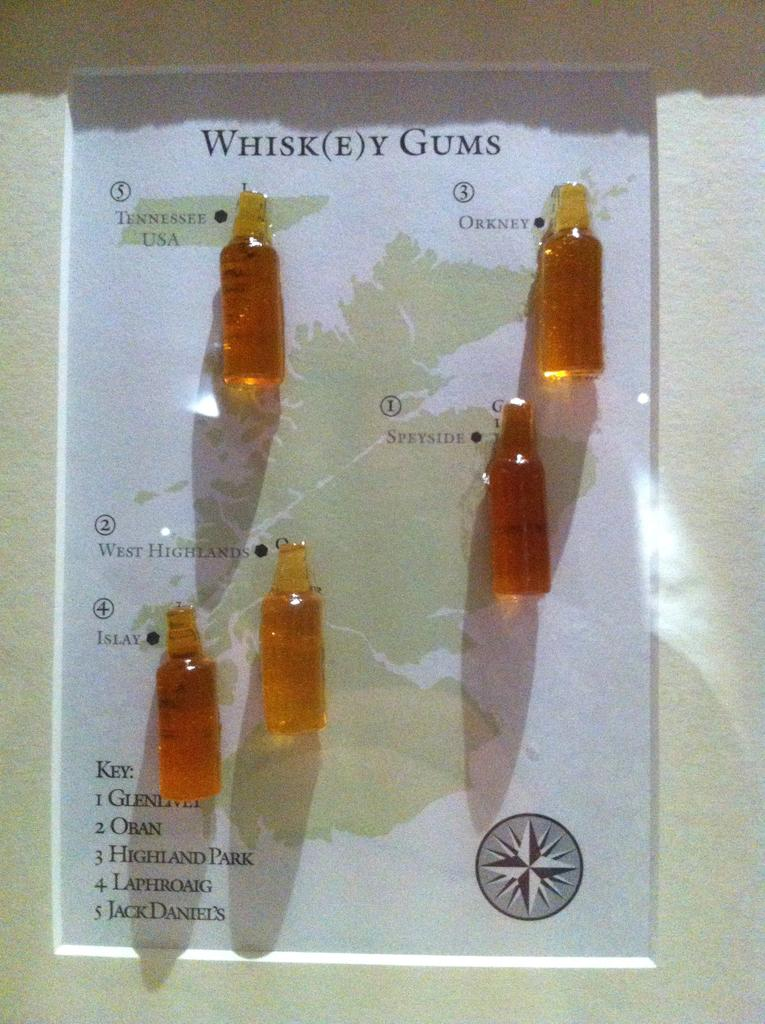<image>
Share a concise interpretation of the image provided. A page with what appear to be whisk(e)y gummies on it. 